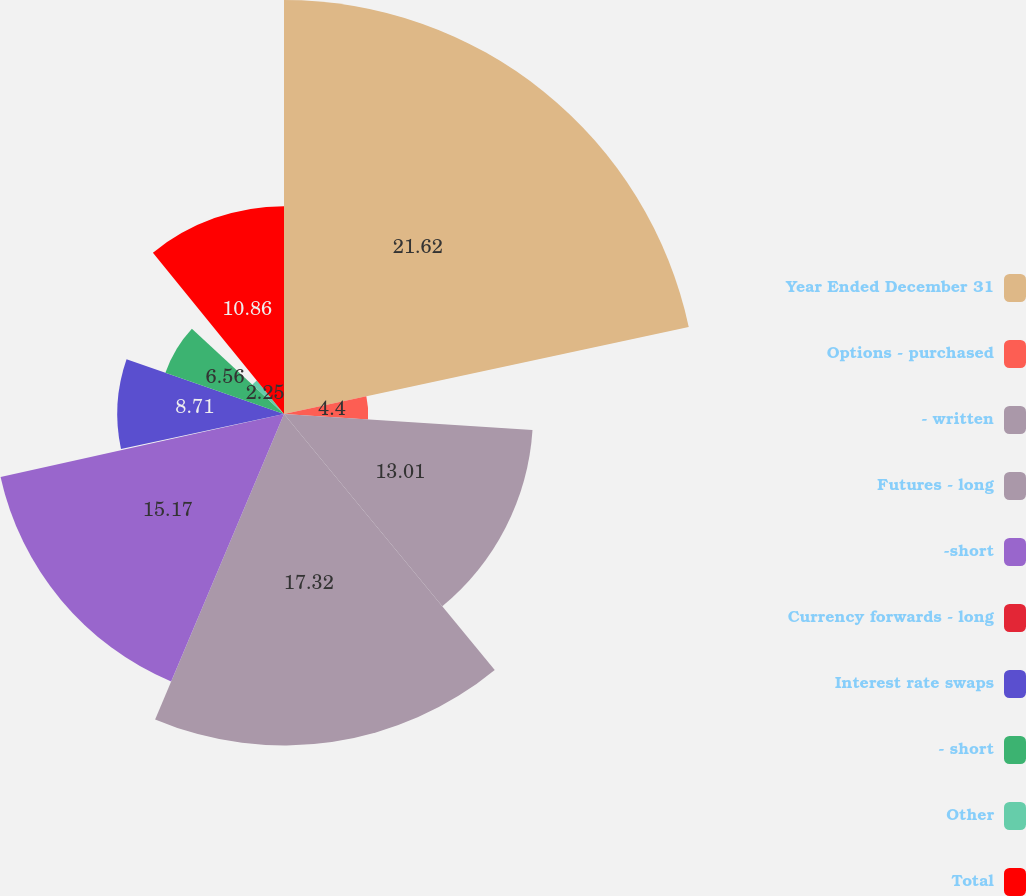<chart> <loc_0><loc_0><loc_500><loc_500><pie_chart><fcel>Year Ended December 31<fcel>Options - purchased<fcel>- written<fcel>Futures - long<fcel>-short<fcel>Currency forwards - long<fcel>Interest rate swaps<fcel>- short<fcel>Other<fcel>Total<nl><fcel>21.63%<fcel>4.4%<fcel>13.01%<fcel>17.32%<fcel>15.17%<fcel>0.1%<fcel>8.71%<fcel>6.56%<fcel>2.25%<fcel>10.86%<nl></chart> 